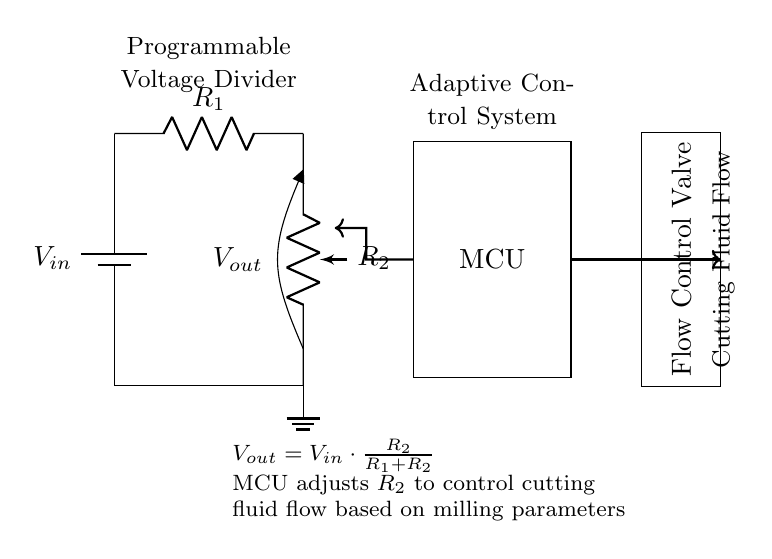What does the microcontroller adjust in this circuit? The microcontroller adjusts the value of the variable resistor, identified as R2, to control the output voltage and subsequently the cutting fluid flow based on milling parameters.
Answer: R2 What is the equation for Vout? The equation for Vout is derived from the voltage divider formula: Vout equals Vin multiplied by the ratio of R2 over the sum of R1 and R2. This is represented in the circuit below the output voltage symbol.
Answer: Vout = Vin * (R2 / (R1 + R2)) What component controls the cutting fluid flow? The flow control valve is responsible for regulating the cutting fluid flow based on the signal received from the microcontroller, which adjusts R2.
Answer: Flow Control Valve What is the role of the battery in this circuit? The battery serves as the power supply, providing the input voltage Vin necessary for the operation of the voltage divider circuit.
Answer: Power supply How does changing R2 affect Vout? By increasing R2, the output voltage Vout increases as the ratio of R2 to R1 + R2 becomes larger. Conversely, decreasing R2 results in a lower Vout due to the reduced ratio, which directly influences the amount of cutting fluid flow.
Answer: Increases or decreases Vout What type of circuit is this? This is a programmable voltage divider circuit designed for adaptive control of cutting fluid flow in milling operations. The programmable aspect allows for dynamic changes to the output voltage.
Answer: Programmable Voltage Divider 